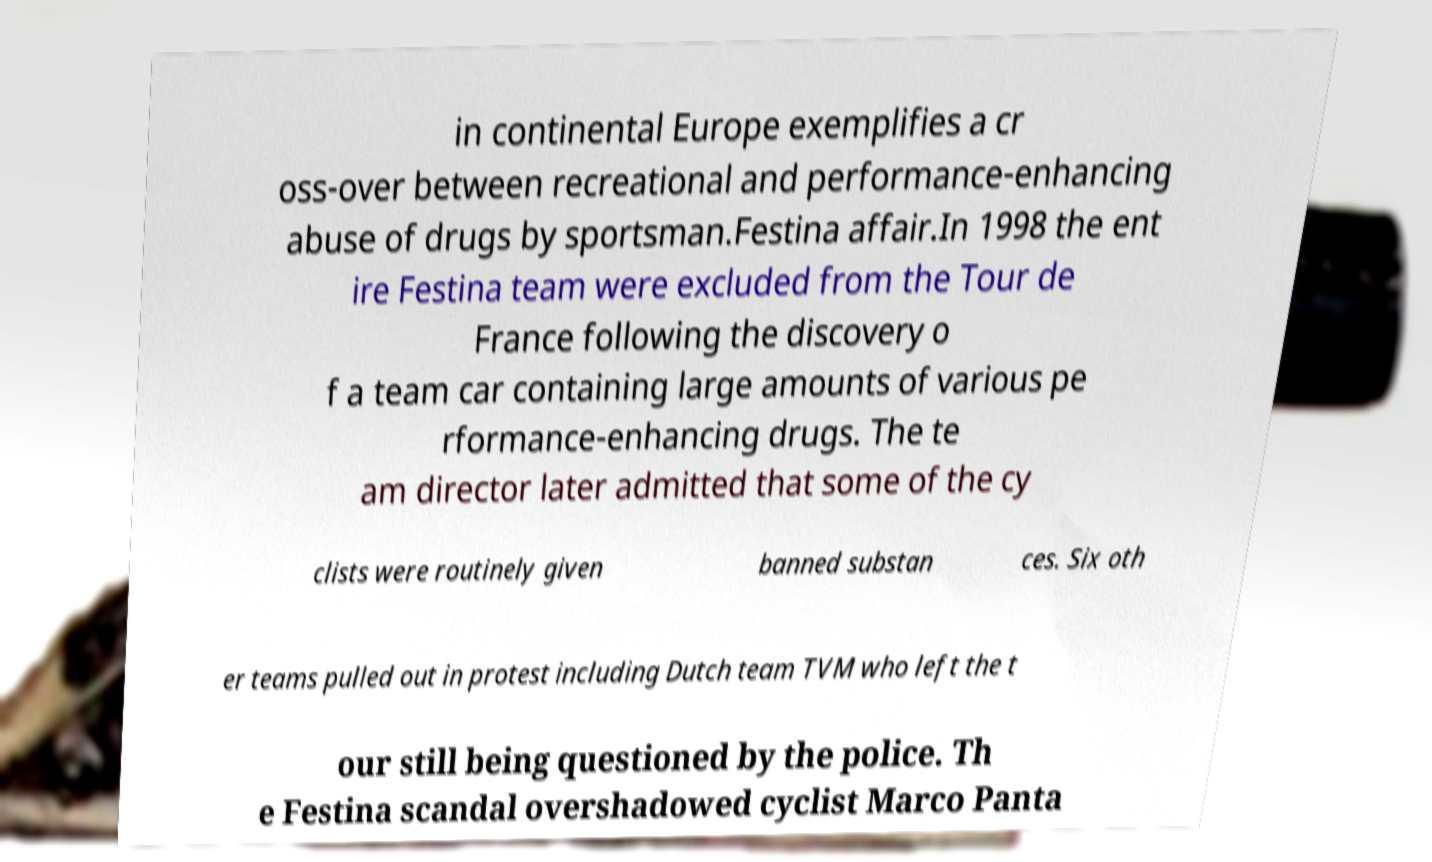Could you extract and type out the text from this image? in continental Europe exemplifies a cr oss-over between recreational and performance-enhancing abuse of drugs by sportsman.Festina affair.In 1998 the ent ire Festina team were excluded from the Tour de France following the discovery o f a team car containing large amounts of various pe rformance-enhancing drugs. The te am director later admitted that some of the cy clists were routinely given banned substan ces. Six oth er teams pulled out in protest including Dutch team TVM who left the t our still being questioned by the police. Th e Festina scandal overshadowed cyclist Marco Panta 